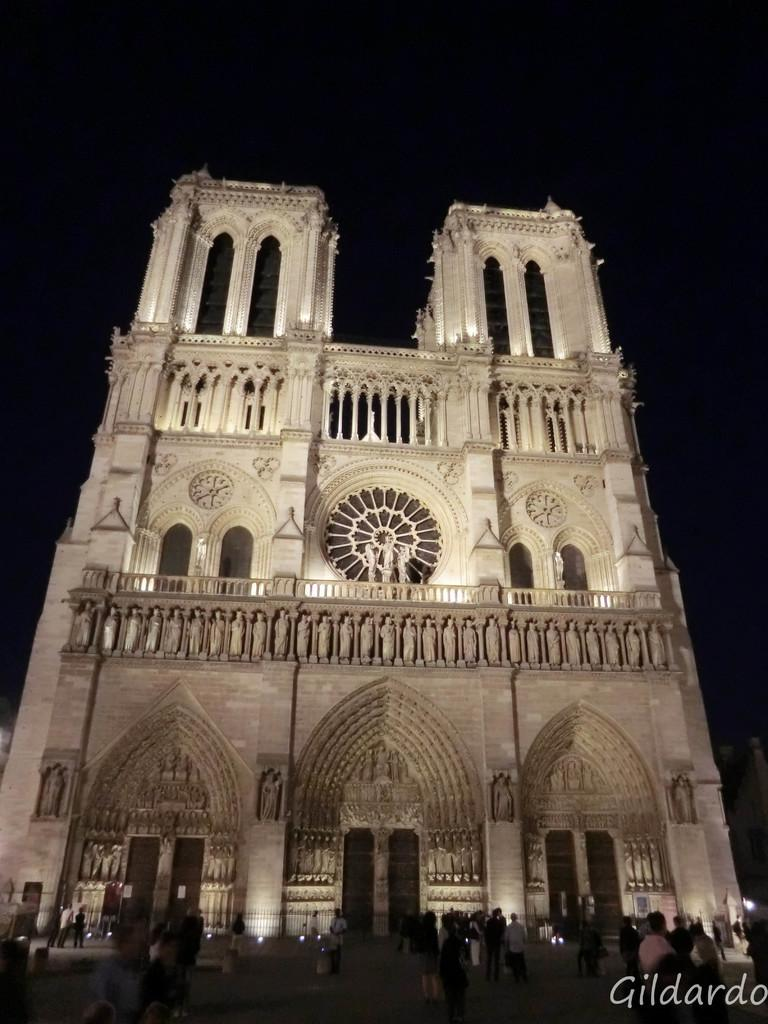What is the main subject in the middle of the image? There is a building in the middle of the image. What can be seen in the background of the image? There is sky visible in the background of the image. What is happening in the foreground of the image? There are persons standing on the floor in the foreground of the image. What is the rate at which the trucks are moving in the image? There are no trucks present in the image, so it is not possible to determine their rate of movement. 